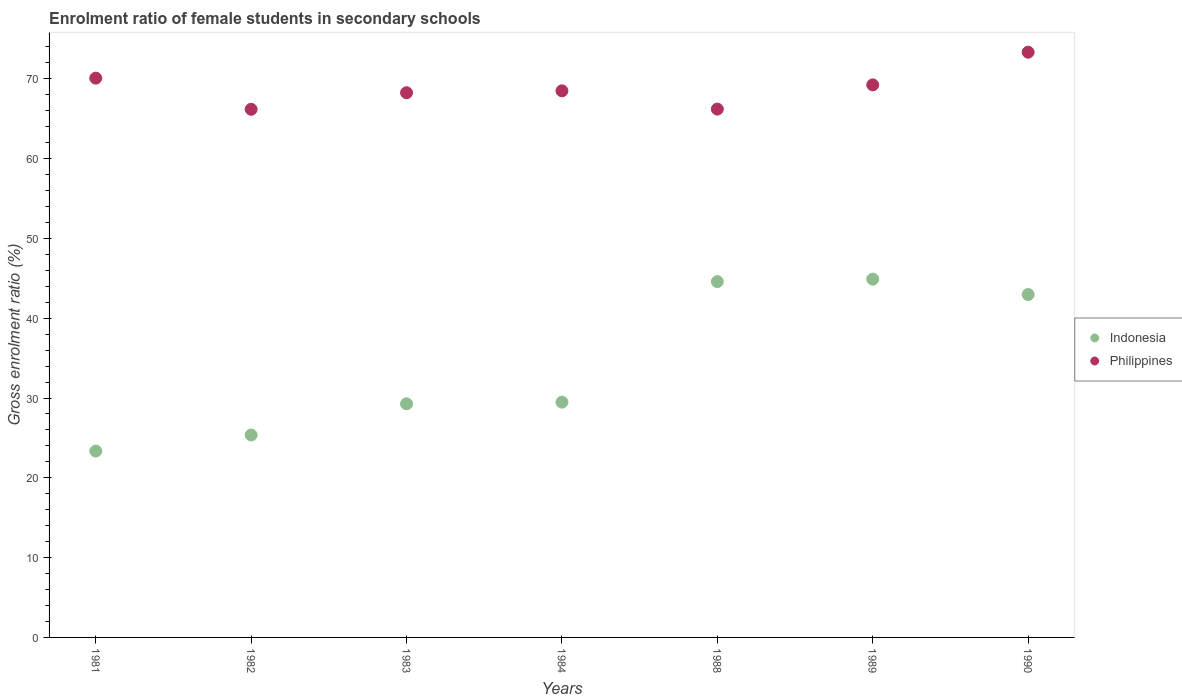How many different coloured dotlines are there?
Offer a terse response. 2. Is the number of dotlines equal to the number of legend labels?
Give a very brief answer. Yes. What is the enrolment ratio of female students in secondary schools in Philippines in 1984?
Offer a very short reply. 68.49. Across all years, what is the maximum enrolment ratio of female students in secondary schools in Indonesia?
Offer a terse response. 44.9. Across all years, what is the minimum enrolment ratio of female students in secondary schools in Indonesia?
Keep it short and to the point. 23.35. What is the total enrolment ratio of female students in secondary schools in Indonesia in the graph?
Give a very brief answer. 239.93. What is the difference between the enrolment ratio of female students in secondary schools in Indonesia in 1982 and that in 1983?
Keep it short and to the point. -3.91. What is the difference between the enrolment ratio of female students in secondary schools in Indonesia in 1984 and the enrolment ratio of female students in secondary schools in Philippines in 1990?
Your response must be concise. -43.85. What is the average enrolment ratio of female students in secondary schools in Indonesia per year?
Your answer should be very brief. 34.28. In the year 1990, what is the difference between the enrolment ratio of female students in secondary schools in Philippines and enrolment ratio of female students in secondary schools in Indonesia?
Make the answer very short. 30.37. What is the ratio of the enrolment ratio of female students in secondary schools in Indonesia in 1989 to that in 1990?
Provide a short and direct response. 1.04. Is the difference between the enrolment ratio of female students in secondary schools in Philippines in 1989 and 1990 greater than the difference between the enrolment ratio of female students in secondary schools in Indonesia in 1989 and 1990?
Provide a succinct answer. No. What is the difference between the highest and the second highest enrolment ratio of female students in secondary schools in Philippines?
Give a very brief answer. 3.25. What is the difference between the highest and the lowest enrolment ratio of female students in secondary schools in Philippines?
Offer a terse response. 7.16. In how many years, is the enrolment ratio of female students in secondary schools in Philippines greater than the average enrolment ratio of female students in secondary schools in Philippines taken over all years?
Provide a succinct answer. 3. Is the sum of the enrolment ratio of female students in secondary schools in Philippines in 1988 and 1989 greater than the maximum enrolment ratio of female students in secondary schools in Indonesia across all years?
Offer a terse response. Yes. Does the enrolment ratio of female students in secondary schools in Philippines monotonically increase over the years?
Offer a terse response. No. How many dotlines are there?
Your response must be concise. 2. How many years are there in the graph?
Your response must be concise. 7. Are the values on the major ticks of Y-axis written in scientific E-notation?
Keep it short and to the point. No. Does the graph contain grids?
Provide a succinct answer. No. Where does the legend appear in the graph?
Ensure brevity in your answer.  Center right. What is the title of the graph?
Offer a very short reply. Enrolment ratio of female students in secondary schools. What is the label or title of the X-axis?
Provide a short and direct response. Years. What is the label or title of the Y-axis?
Make the answer very short. Gross enrolment ratio (%). What is the Gross enrolment ratio (%) in Indonesia in 1981?
Offer a very short reply. 23.35. What is the Gross enrolment ratio (%) of Philippines in 1981?
Make the answer very short. 70.08. What is the Gross enrolment ratio (%) in Indonesia in 1982?
Your response must be concise. 25.37. What is the Gross enrolment ratio (%) in Philippines in 1982?
Make the answer very short. 66.18. What is the Gross enrolment ratio (%) of Indonesia in 1983?
Provide a short and direct response. 29.27. What is the Gross enrolment ratio (%) in Philippines in 1983?
Provide a short and direct response. 68.25. What is the Gross enrolment ratio (%) of Indonesia in 1984?
Your response must be concise. 29.48. What is the Gross enrolment ratio (%) of Philippines in 1984?
Give a very brief answer. 68.49. What is the Gross enrolment ratio (%) in Indonesia in 1988?
Your answer should be very brief. 44.59. What is the Gross enrolment ratio (%) in Philippines in 1988?
Provide a short and direct response. 66.21. What is the Gross enrolment ratio (%) in Indonesia in 1989?
Provide a succinct answer. 44.9. What is the Gross enrolment ratio (%) in Philippines in 1989?
Provide a succinct answer. 69.24. What is the Gross enrolment ratio (%) in Indonesia in 1990?
Provide a short and direct response. 42.97. What is the Gross enrolment ratio (%) in Philippines in 1990?
Provide a succinct answer. 73.34. Across all years, what is the maximum Gross enrolment ratio (%) in Indonesia?
Give a very brief answer. 44.9. Across all years, what is the maximum Gross enrolment ratio (%) of Philippines?
Provide a short and direct response. 73.34. Across all years, what is the minimum Gross enrolment ratio (%) of Indonesia?
Give a very brief answer. 23.35. Across all years, what is the minimum Gross enrolment ratio (%) of Philippines?
Offer a very short reply. 66.18. What is the total Gross enrolment ratio (%) in Indonesia in the graph?
Offer a very short reply. 239.93. What is the total Gross enrolment ratio (%) of Philippines in the graph?
Keep it short and to the point. 481.8. What is the difference between the Gross enrolment ratio (%) of Indonesia in 1981 and that in 1982?
Provide a short and direct response. -2.02. What is the difference between the Gross enrolment ratio (%) of Philippines in 1981 and that in 1982?
Offer a very short reply. 3.9. What is the difference between the Gross enrolment ratio (%) in Indonesia in 1981 and that in 1983?
Offer a terse response. -5.92. What is the difference between the Gross enrolment ratio (%) of Philippines in 1981 and that in 1983?
Your answer should be very brief. 1.83. What is the difference between the Gross enrolment ratio (%) of Indonesia in 1981 and that in 1984?
Provide a succinct answer. -6.13. What is the difference between the Gross enrolment ratio (%) of Philippines in 1981 and that in 1984?
Your answer should be very brief. 1.59. What is the difference between the Gross enrolment ratio (%) in Indonesia in 1981 and that in 1988?
Your response must be concise. -21.24. What is the difference between the Gross enrolment ratio (%) of Philippines in 1981 and that in 1988?
Ensure brevity in your answer.  3.88. What is the difference between the Gross enrolment ratio (%) in Indonesia in 1981 and that in 1989?
Ensure brevity in your answer.  -21.54. What is the difference between the Gross enrolment ratio (%) of Philippines in 1981 and that in 1989?
Your answer should be very brief. 0.84. What is the difference between the Gross enrolment ratio (%) of Indonesia in 1981 and that in 1990?
Make the answer very short. -19.62. What is the difference between the Gross enrolment ratio (%) of Philippines in 1981 and that in 1990?
Your answer should be very brief. -3.25. What is the difference between the Gross enrolment ratio (%) of Indonesia in 1982 and that in 1983?
Provide a succinct answer. -3.91. What is the difference between the Gross enrolment ratio (%) in Philippines in 1982 and that in 1983?
Your answer should be compact. -2.07. What is the difference between the Gross enrolment ratio (%) in Indonesia in 1982 and that in 1984?
Ensure brevity in your answer.  -4.12. What is the difference between the Gross enrolment ratio (%) in Philippines in 1982 and that in 1984?
Your response must be concise. -2.31. What is the difference between the Gross enrolment ratio (%) of Indonesia in 1982 and that in 1988?
Offer a very short reply. -19.22. What is the difference between the Gross enrolment ratio (%) in Philippines in 1982 and that in 1988?
Ensure brevity in your answer.  -0.02. What is the difference between the Gross enrolment ratio (%) of Indonesia in 1982 and that in 1989?
Offer a terse response. -19.53. What is the difference between the Gross enrolment ratio (%) in Philippines in 1982 and that in 1989?
Make the answer very short. -3.06. What is the difference between the Gross enrolment ratio (%) in Indonesia in 1982 and that in 1990?
Provide a short and direct response. -17.6. What is the difference between the Gross enrolment ratio (%) in Philippines in 1982 and that in 1990?
Make the answer very short. -7.16. What is the difference between the Gross enrolment ratio (%) in Indonesia in 1983 and that in 1984?
Ensure brevity in your answer.  -0.21. What is the difference between the Gross enrolment ratio (%) of Philippines in 1983 and that in 1984?
Offer a terse response. -0.24. What is the difference between the Gross enrolment ratio (%) in Indonesia in 1983 and that in 1988?
Offer a terse response. -15.31. What is the difference between the Gross enrolment ratio (%) in Philippines in 1983 and that in 1988?
Offer a terse response. 2.05. What is the difference between the Gross enrolment ratio (%) of Indonesia in 1983 and that in 1989?
Offer a terse response. -15.62. What is the difference between the Gross enrolment ratio (%) of Philippines in 1983 and that in 1989?
Give a very brief answer. -0.99. What is the difference between the Gross enrolment ratio (%) of Indonesia in 1983 and that in 1990?
Give a very brief answer. -13.7. What is the difference between the Gross enrolment ratio (%) of Philippines in 1983 and that in 1990?
Give a very brief answer. -5.08. What is the difference between the Gross enrolment ratio (%) of Indonesia in 1984 and that in 1988?
Keep it short and to the point. -15.1. What is the difference between the Gross enrolment ratio (%) of Philippines in 1984 and that in 1988?
Your response must be concise. 2.29. What is the difference between the Gross enrolment ratio (%) in Indonesia in 1984 and that in 1989?
Offer a terse response. -15.41. What is the difference between the Gross enrolment ratio (%) in Philippines in 1984 and that in 1989?
Provide a short and direct response. -0.75. What is the difference between the Gross enrolment ratio (%) of Indonesia in 1984 and that in 1990?
Your response must be concise. -13.49. What is the difference between the Gross enrolment ratio (%) in Philippines in 1984 and that in 1990?
Your answer should be very brief. -4.84. What is the difference between the Gross enrolment ratio (%) of Indonesia in 1988 and that in 1989?
Your answer should be very brief. -0.31. What is the difference between the Gross enrolment ratio (%) of Philippines in 1988 and that in 1989?
Offer a terse response. -3.04. What is the difference between the Gross enrolment ratio (%) in Indonesia in 1988 and that in 1990?
Offer a terse response. 1.62. What is the difference between the Gross enrolment ratio (%) of Philippines in 1988 and that in 1990?
Offer a very short reply. -7.13. What is the difference between the Gross enrolment ratio (%) in Indonesia in 1989 and that in 1990?
Offer a very short reply. 1.93. What is the difference between the Gross enrolment ratio (%) of Philippines in 1989 and that in 1990?
Provide a succinct answer. -4.09. What is the difference between the Gross enrolment ratio (%) of Indonesia in 1981 and the Gross enrolment ratio (%) of Philippines in 1982?
Give a very brief answer. -42.83. What is the difference between the Gross enrolment ratio (%) of Indonesia in 1981 and the Gross enrolment ratio (%) of Philippines in 1983?
Give a very brief answer. -44.9. What is the difference between the Gross enrolment ratio (%) in Indonesia in 1981 and the Gross enrolment ratio (%) in Philippines in 1984?
Your answer should be very brief. -45.14. What is the difference between the Gross enrolment ratio (%) of Indonesia in 1981 and the Gross enrolment ratio (%) of Philippines in 1988?
Keep it short and to the point. -42.85. What is the difference between the Gross enrolment ratio (%) of Indonesia in 1981 and the Gross enrolment ratio (%) of Philippines in 1989?
Offer a terse response. -45.89. What is the difference between the Gross enrolment ratio (%) of Indonesia in 1981 and the Gross enrolment ratio (%) of Philippines in 1990?
Your answer should be compact. -49.98. What is the difference between the Gross enrolment ratio (%) in Indonesia in 1982 and the Gross enrolment ratio (%) in Philippines in 1983?
Ensure brevity in your answer.  -42.89. What is the difference between the Gross enrolment ratio (%) in Indonesia in 1982 and the Gross enrolment ratio (%) in Philippines in 1984?
Offer a terse response. -43.13. What is the difference between the Gross enrolment ratio (%) in Indonesia in 1982 and the Gross enrolment ratio (%) in Philippines in 1988?
Offer a terse response. -40.84. What is the difference between the Gross enrolment ratio (%) of Indonesia in 1982 and the Gross enrolment ratio (%) of Philippines in 1989?
Your answer should be compact. -43.87. What is the difference between the Gross enrolment ratio (%) in Indonesia in 1982 and the Gross enrolment ratio (%) in Philippines in 1990?
Provide a succinct answer. -47.97. What is the difference between the Gross enrolment ratio (%) of Indonesia in 1983 and the Gross enrolment ratio (%) of Philippines in 1984?
Offer a very short reply. -39.22. What is the difference between the Gross enrolment ratio (%) in Indonesia in 1983 and the Gross enrolment ratio (%) in Philippines in 1988?
Offer a very short reply. -36.93. What is the difference between the Gross enrolment ratio (%) of Indonesia in 1983 and the Gross enrolment ratio (%) of Philippines in 1989?
Your answer should be very brief. -39.97. What is the difference between the Gross enrolment ratio (%) in Indonesia in 1983 and the Gross enrolment ratio (%) in Philippines in 1990?
Ensure brevity in your answer.  -44.06. What is the difference between the Gross enrolment ratio (%) in Indonesia in 1984 and the Gross enrolment ratio (%) in Philippines in 1988?
Make the answer very short. -36.72. What is the difference between the Gross enrolment ratio (%) of Indonesia in 1984 and the Gross enrolment ratio (%) of Philippines in 1989?
Offer a terse response. -39.76. What is the difference between the Gross enrolment ratio (%) in Indonesia in 1984 and the Gross enrolment ratio (%) in Philippines in 1990?
Your response must be concise. -43.85. What is the difference between the Gross enrolment ratio (%) in Indonesia in 1988 and the Gross enrolment ratio (%) in Philippines in 1989?
Ensure brevity in your answer.  -24.65. What is the difference between the Gross enrolment ratio (%) in Indonesia in 1988 and the Gross enrolment ratio (%) in Philippines in 1990?
Offer a terse response. -28.75. What is the difference between the Gross enrolment ratio (%) of Indonesia in 1989 and the Gross enrolment ratio (%) of Philippines in 1990?
Provide a short and direct response. -28.44. What is the average Gross enrolment ratio (%) of Indonesia per year?
Your response must be concise. 34.28. What is the average Gross enrolment ratio (%) of Philippines per year?
Make the answer very short. 68.83. In the year 1981, what is the difference between the Gross enrolment ratio (%) in Indonesia and Gross enrolment ratio (%) in Philippines?
Your response must be concise. -46.73. In the year 1982, what is the difference between the Gross enrolment ratio (%) of Indonesia and Gross enrolment ratio (%) of Philippines?
Provide a succinct answer. -40.81. In the year 1983, what is the difference between the Gross enrolment ratio (%) in Indonesia and Gross enrolment ratio (%) in Philippines?
Offer a terse response. -38.98. In the year 1984, what is the difference between the Gross enrolment ratio (%) in Indonesia and Gross enrolment ratio (%) in Philippines?
Your response must be concise. -39.01. In the year 1988, what is the difference between the Gross enrolment ratio (%) of Indonesia and Gross enrolment ratio (%) of Philippines?
Your response must be concise. -21.62. In the year 1989, what is the difference between the Gross enrolment ratio (%) in Indonesia and Gross enrolment ratio (%) in Philippines?
Provide a succinct answer. -24.35. In the year 1990, what is the difference between the Gross enrolment ratio (%) in Indonesia and Gross enrolment ratio (%) in Philippines?
Your answer should be compact. -30.37. What is the ratio of the Gross enrolment ratio (%) of Indonesia in 1981 to that in 1982?
Your answer should be compact. 0.92. What is the ratio of the Gross enrolment ratio (%) in Philippines in 1981 to that in 1982?
Your answer should be very brief. 1.06. What is the ratio of the Gross enrolment ratio (%) of Indonesia in 1981 to that in 1983?
Your answer should be very brief. 0.8. What is the ratio of the Gross enrolment ratio (%) in Philippines in 1981 to that in 1983?
Offer a very short reply. 1.03. What is the ratio of the Gross enrolment ratio (%) in Indonesia in 1981 to that in 1984?
Your answer should be very brief. 0.79. What is the ratio of the Gross enrolment ratio (%) of Philippines in 1981 to that in 1984?
Give a very brief answer. 1.02. What is the ratio of the Gross enrolment ratio (%) of Indonesia in 1981 to that in 1988?
Offer a terse response. 0.52. What is the ratio of the Gross enrolment ratio (%) of Philippines in 1981 to that in 1988?
Offer a very short reply. 1.06. What is the ratio of the Gross enrolment ratio (%) of Indonesia in 1981 to that in 1989?
Ensure brevity in your answer.  0.52. What is the ratio of the Gross enrolment ratio (%) of Philippines in 1981 to that in 1989?
Give a very brief answer. 1.01. What is the ratio of the Gross enrolment ratio (%) in Indonesia in 1981 to that in 1990?
Give a very brief answer. 0.54. What is the ratio of the Gross enrolment ratio (%) of Philippines in 1981 to that in 1990?
Give a very brief answer. 0.96. What is the ratio of the Gross enrolment ratio (%) in Indonesia in 1982 to that in 1983?
Your answer should be very brief. 0.87. What is the ratio of the Gross enrolment ratio (%) of Philippines in 1982 to that in 1983?
Provide a succinct answer. 0.97. What is the ratio of the Gross enrolment ratio (%) in Indonesia in 1982 to that in 1984?
Make the answer very short. 0.86. What is the ratio of the Gross enrolment ratio (%) of Philippines in 1982 to that in 1984?
Offer a very short reply. 0.97. What is the ratio of the Gross enrolment ratio (%) of Indonesia in 1982 to that in 1988?
Your response must be concise. 0.57. What is the ratio of the Gross enrolment ratio (%) of Philippines in 1982 to that in 1988?
Your response must be concise. 1. What is the ratio of the Gross enrolment ratio (%) in Indonesia in 1982 to that in 1989?
Make the answer very short. 0.57. What is the ratio of the Gross enrolment ratio (%) in Philippines in 1982 to that in 1989?
Provide a short and direct response. 0.96. What is the ratio of the Gross enrolment ratio (%) in Indonesia in 1982 to that in 1990?
Keep it short and to the point. 0.59. What is the ratio of the Gross enrolment ratio (%) in Philippines in 1982 to that in 1990?
Ensure brevity in your answer.  0.9. What is the ratio of the Gross enrolment ratio (%) in Indonesia in 1983 to that in 1984?
Your response must be concise. 0.99. What is the ratio of the Gross enrolment ratio (%) in Philippines in 1983 to that in 1984?
Your answer should be very brief. 1. What is the ratio of the Gross enrolment ratio (%) of Indonesia in 1983 to that in 1988?
Your response must be concise. 0.66. What is the ratio of the Gross enrolment ratio (%) of Philippines in 1983 to that in 1988?
Your answer should be compact. 1.03. What is the ratio of the Gross enrolment ratio (%) in Indonesia in 1983 to that in 1989?
Provide a succinct answer. 0.65. What is the ratio of the Gross enrolment ratio (%) of Philippines in 1983 to that in 1989?
Provide a succinct answer. 0.99. What is the ratio of the Gross enrolment ratio (%) in Indonesia in 1983 to that in 1990?
Make the answer very short. 0.68. What is the ratio of the Gross enrolment ratio (%) in Philippines in 1983 to that in 1990?
Give a very brief answer. 0.93. What is the ratio of the Gross enrolment ratio (%) of Indonesia in 1984 to that in 1988?
Give a very brief answer. 0.66. What is the ratio of the Gross enrolment ratio (%) in Philippines in 1984 to that in 1988?
Your answer should be very brief. 1.03. What is the ratio of the Gross enrolment ratio (%) of Indonesia in 1984 to that in 1989?
Offer a terse response. 0.66. What is the ratio of the Gross enrolment ratio (%) in Indonesia in 1984 to that in 1990?
Your answer should be very brief. 0.69. What is the ratio of the Gross enrolment ratio (%) of Philippines in 1984 to that in 1990?
Provide a short and direct response. 0.93. What is the ratio of the Gross enrolment ratio (%) of Indonesia in 1988 to that in 1989?
Ensure brevity in your answer.  0.99. What is the ratio of the Gross enrolment ratio (%) in Philippines in 1988 to that in 1989?
Your answer should be very brief. 0.96. What is the ratio of the Gross enrolment ratio (%) of Indonesia in 1988 to that in 1990?
Give a very brief answer. 1.04. What is the ratio of the Gross enrolment ratio (%) of Philippines in 1988 to that in 1990?
Offer a very short reply. 0.9. What is the ratio of the Gross enrolment ratio (%) in Indonesia in 1989 to that in 1990?
Give a very brief answer. 1.04. What is the ratio of the Gross enrolment ratio (%) in Philippines in 1989 to that in 1990?
Provide a succinct answer. 0.94. What is the difference between the highest and the second highest Gross enrolment ratio (%) in Indonesia?
Your response must be concise. 0.31. What is the difference between the highest and the second highest Gross enrolment ratio (%) of Philippines?
Your answer should be compact. 3.25. What is the difference between the highest and the lowest Gross enrolment ratio (%) in Indonesia?
Make the answer very short. 21.54. What is the difference between the highest and the lowest Gross enrolment ratio (%) in Philippines?
Make the answer very short. 7.16. 